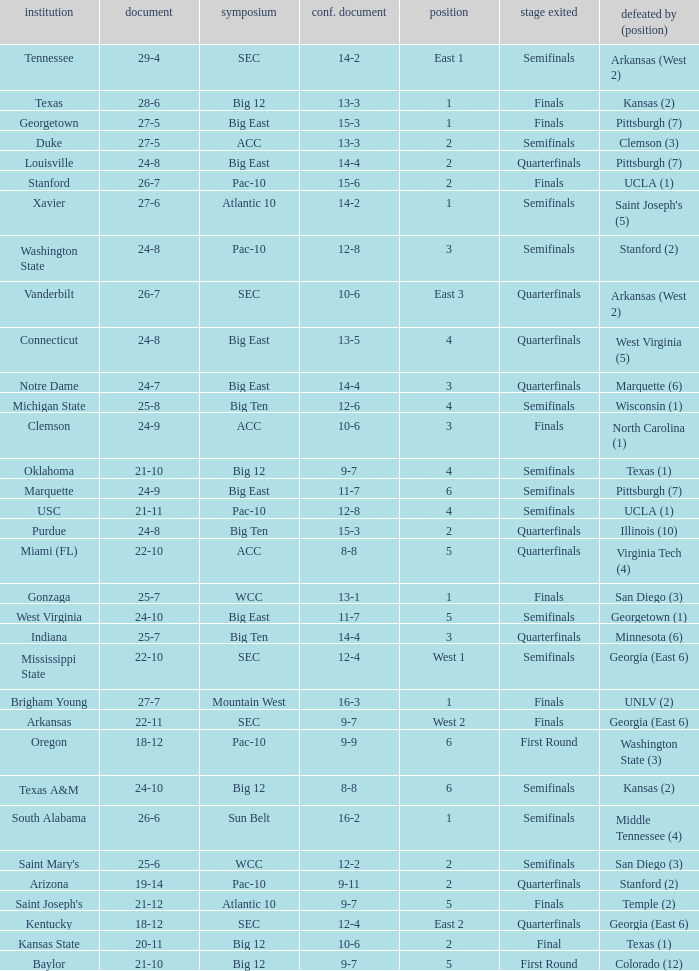Name the school where conference record is 12-6 Michigan State. 